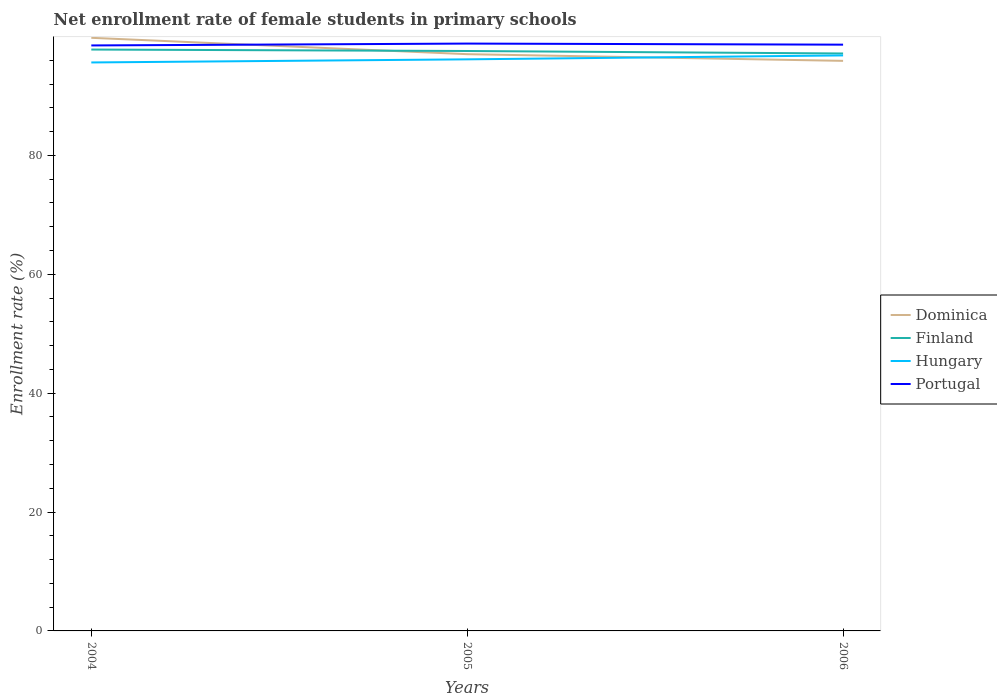Is the number of lines equal to the number of legend labels?
Offer a very short reply. Yes. Across all years, what is the maximum net enrollment rate of female students in primary schools in Finland?
Offer a terse response. 97.15. In which year was the net enrollment rate of female students in primary schools in Portugal maximum?
Your answer should be compact. 2004. What is the total net enrollment rate of female students in primary schools in Hungary in the graph?
Keep it short and to the point. -1.19. What is the difference between the highest and the second highest net enrollment rate of female students in primary schools in Portugal?
Provide a succinct answer. 0.31. Is the net enrollment rate of female students in primary schools in Hungary strictly greater than the net enrollment rate of female students in primary schools in Portugal over the years?
Ensure brevity in your answer.  Yes. What is the difference between two consecutive major ticks on the Y-axis?
Give a very brief answer. 20. Are the values on the major ticks of Y-axis written in scientific E-notation?
Offer a terse response. No. Does the graph contain grids?
Your answer should be compact. No. Where does the legend appear in the graph?
Your response must be concise. Center right. How are the legend labels stacked?
Your answer should be compact. Vertical. What is the title of the graph?
Your response must be concise. Net enrollment rate of female students in primary schools. What is the label or title of the X-axis?
Offer a terse response. Years. What is the label or title of the Y-axis?
Offer a very short reply. Enrollment rate (%). What is the Enrollment rate (%) of Dominica in 2004?
Provide a short and direct response. 99.79. What is the Enrollment rate (%) of Finland in 2004?
Your answer should be very brief. 97.82. What is the Enrollment rate (%) in Hungary in 2004?
Provide a succinct answer. 95.64. What is the Enrollment rate (%) of Portugal in 2004?
Make the answer very short. 98.51. What is the Enrollment rate (%) in Dominica in 2005?
Offer a very short reply. 97.04. What is the Enrollment rate (%) of Finland in 2005?
Your answer should be compact. 97.57. What is the Enrollment rate (%) of Hungary in 2005?
Make the answer very short. 96.17. What is the Enrollment rate (%) of Portugal in 2005?
Provide a succinct answer. 98.82. What is the Enrollment rate (%) in Dominica in 2006?
Make the answer very short. 95.91. What is the Enrollment rate (%) in Finland in 2006?
Keep it short and to the point. 97.15. What is the Enrollment rate (%) in Hungary in 2006?
Provide a short and direct response. 96.83. What is the Enrollment rate (%) of Portugal in 2006?
Ensure brevity in your answer.  98.64. Across all years, what is the maximum Enrollment rate (%) of Dominica?
Make the answer very short. 99.79. Across all years, what is the maximum Enrollment rate (%) in Finland?
Your answer should be compact. 97.82. Across all years, what is the maximum Enrollment rate (%) of Hungary?
Your response must be concise. 96.83. Across all years, what is the maximum Enrollment rate (%) of Portugal?
Provide a short and direct response. 98.82. Across all years, what is the minimum Enrollment rate (%) in Dominica?
Your answer should be very brief. 95.91. Across all years, what is the minimum Enrollment rate (%) of Finland?
Provide a succinct answer. 97.15. Across all years, what is the minimum Enrollment rate (%) in Hungary?
Your response must be concise. 95.64. Across all years, what is the minimum Enrollment rate (%) of Portugal?
Give a very brief answer. 98.51. What is the total Enrollment rate (%) in Dominica in the graph?
Your answer should be very brief. 292.74. What is the total Enrollment rate (%) of Finland in the graph?
Offer a terse response. 292.54. What is the total Enrollment rate (%) in Hungary in the graph?
Ensure brevity in your answer.  288.64. What is the total Enrollment rate (%) of Portugal in the graph?
Your response must be concise. 295.96. What is the difference between the Enrollment rate (%) of Dominica in 2004 and that in 2005?
Offer a very short reply. 2.75. What is the difference between the Enrollment rate (%) of Finland in 2004 and that in 2005?
Make the answer very short. 0.24. What is the difference between the Enrollment rate (%) of Hungary in 2004 and that in 2005?
Offer a terse response. -0.52. What is the difference between the Enrollment rate (%) of Portugal in 2004 and that in 2005?
Provide a short and direct response. -0.31. What is the difference between the Enrollment rate (%) in Dominica in 2004 and that in 2006?
Provide a succinct answer. 3.88. What is the difference between the Enrollment rate (%) of Finland in 2004 and that in 2006?
Ensure brevity in your answer.  0.66. What is the difference between the Enrollment rate (%) in Hungary in 2004 and that in 2006?
Ensure brevity in your answer.  -1.19. What is the difference between the Enrollment rate (%) in Portugal in 2004 and that in 2006?
Provide a short and direct response. -0.13. What is the difference between the Enrollment rate (%) in Dominica in 2005 and that in 2006?
Offer a very short reply. 1.12. What is the difference between the Enrollment rate (%) in Finland in 2005 and that in 2006?
Make the answer very short. 0.42. What is the difference between the Enrollment rate (%) in Hungary in 2005 and that in 2006?
Your answer should be compact. -0.66. What is the difference between the Enrollment rate (%) in Portugal in 2005 and that in 2006?
Your answer should be very brief. 0.18. What is the difference between the Enrollment rate (%) of Dominica in 2004 and the Enrollment rate (%) of Finland in 2005?
Provide a short and direct response. 2.22. What is the difference between the Enrollment rate (%) of Dominica in 2004 and the Enrollment rate (%) of Hungary in 2005?
Give a very brief answer. 3.62. What is the difference between the Enrollment rate (%) of Dominica in 2004 and the Enrollment rate (%) of Portugal in 2005?
Your answer should be compact. 0.97. What is the difference between the Enrollment rate (%) of Finland in 2004 and the Enrollment rate (%) of Hungary in 2005?
Ensure brevity in your answer.  1.65. What is the difference between the Enrollment rate (%) in Finland in 2004 and the Enrollment rate (%) in Portugal in 2005?
Give a very brief answer. -1. What is the difference between the Enrollment rate (%) of Hungary in 2004 and the Enrollment rate (%) of Portugal in 2005?
Offer a terse response. -3.18. What is the difference between the Enrollment rate (%) in Dominica in 2004 and the Enrollment rate (%) in Finland in 2006?
Keep it short and to the point. 2.64. What is the difference between the Enrollment rate (%) of Dominica in 2004 and the Enrollment rate (%) of Hungary in 2006?
Keep it short and to the point. 2.96. What is the difference between the Enrollment rate (%) in Dominica in 2004 and the Enrollment rate (%) in Portugal in 2006?
Offer a very short reply. 1.15. What is the difference between the Enrollment rate (%) of Finland in 2004 and the Enrollment rate (%) of Hungary in 2006?
Provide a succinct answer. 0.99. What is the difference between the Enrollment rate (%) in Finland in 2004 and the Enrollment rate (%) in Portugal in 2006?
Provide a short and direct response. -0.82. What is the difference between the Enrollment rate (%) of Hungary in 2004 and the Enrollment rate (%) of Portugal in 2006?
Give a very brief answer. -2.99. What is the difference between the Enrollment rate (%) of Dominica in 2005 and the Enrollment rate (%) of Finland in 2006?
Offer a very short reply. -0.12. What is the difference between the Enrollment rate (%) of Dominica in 2005 and the Enrollment rate (%) of Hungary in 2006?
Your answer should be compact. 0.21. What is the difference between the Enrollment rate (%) in Dominica in 2005 and the Enrollment rate (%) in Portugal in 2006?
Your response must be concise. -1.6. What is the difference between the Enrollment rate (%) of Finland in 2005 and the Enrollment rate (%) of Hungary in 2006?
Ensure brevity in your answer.  0.74. What is the difference between the Enrollment rate (%) in Finland in 2005 and the Enrollment rate (%) in Portugal in 2006?
Offer a terse response. -1.07. What is the difference between the Enrollment rate (%) of Hungary in 2005 and the Enrollment rate (%) of Portugal in 2006?
Your response must be concise. -2.47. What is the average Enrollment rate (%) in Dominica per year?
Ensure brevity in your answer.  97.58. What is the average Enrollment rate (%) in Finland per year?
Provide a short and direct response. 97.51. What is the average Enrollment rate (%) of Hungary per year?
Provide a succinct answer. 96.21. What is the average Enrollment rate (%) in Portugal per year?
Offer a terse response. 98.65. In the year 2004, what is the difference between the Enrollment rate (%) in Dominica and Enrollment rate (%) in Finland?
Offer a terse response. 1.97. In the year 2004, what is the difference between the Enrollment rate (%) in Dominica and Enrollment rate (%) in Hungary?
Your answer should be compact. 4.15. In the year 2004, what is the difference between the Enrollment rate (%) in Dominica and Enrollment rate (%) in Portugal?
Ensure brevity in your answer.  1.28. In the year 2004, what is the difference between the Enrollment rate (%) in Finland and Enrollment rate (%) in Hungary?
Provide a short and direct response. 2.17. In the year 2004, what is the difference between the Enrollment rate (%) in Finland and Enrollment rate (%) in Portugal?
Provide a short and direct response. -0.69. In the year 2004, what is the difference between the Enrollment rate (%) in Hungary and Enrollment rate (%) in Portugal?
Your answer should be compact. -2.87. In the year 2005, what is the difference between the Enrollment rate (%) in Dominica and Enrollment rate (%) in Finland?
Provide a succinct answer. -0.53. In the year 2005, what is the difference between the Enrollment rate (%) in Dominica and Enrollment rate (%) in Hungary?
Give a very brief answer. 0.87. In the year 2005, what is the difference between the Enrollment rate (%) of Dominica and Enrollment rate (%) of Portugal?
Your answer should be very brief. -1.78. In the year 2005, what is the difference between the Enrollment rate (%) of Finland and Enrollment rate (%) of Hungary?
Provide a short and direct response. 1.41. In the year 2005, what is the difference between the Enrollment rate (%) of Finland and Enrollment rate (%) of Portugal?
Your response must be concise. -1.25. In the year 2005, what is the difference between the Enrollment rate (%) in Hungary and Enrollment rate (%) in Portugal?
Your answer should be compact. -2.65. In the year 2006, what is the difference between the Enrollment rate (%) of Dominica and Enrollment rate (%) of Finland?
Make the answer very short. -1.24. In the year 2006, what is the difference between the Enrollment rate (%) of Dominica and Enrollment rate (%) of Hungary?
Provide a short and direct response. -0.92. In the year 2006, what is the difference between the Enrollment rate (%) in Dominica and Enrollment rate (%) in Portugal?
Your answer should be compact. -2.72. In the year 2006, what is the difference between the Enrollment rate (%) in Finland and Enrollment rate (%) in Hungary?
Ensure brevity in your answer.  0.33. In the year 2006, what is the difference between the Enrollment rate (%) in Finland and Enrollment rate (%) in Portugal?
Provide a short and direct response. -1.48. In the year 2006, what is the difference between the Enrollment rate (%) in Hungary and Enrollment rate (%) in Portugal?
Your response must be concise. -1.81. What is the ratio of the Enrollment rate (%) in Dominica in 2004 to that in 2005?
Provide a short and direct response. 1.03. What is the ratio of the Enrollment rate (%) of Portugal in 2004 to that in 2005?
Keep it short and to the point. 1. What is the ratio of the Enrollment rate (%) in Dominica in 2004 to that in 2006?
Keep it short and to the point. 1.04. What is the ratio of the Enrollment rate (%) in Finland in 2004 to that in 2006?
Keep it short and to the point. 1.01. What is the ratio of the Enrollment rate (%) of Hungary in 2004 to that in 2006?
Give a very brief answer. 0.99. What is the ratio of the Enrollment rate (%) in Portugal in 2004 to that in 2006?
Provide a short and direct response. 1. What is the ratio of the Enrollment rate (%) in Dominica in 2005 to that in 2006?
Provide a succinct answer. 1.01. What is the ratio of the Enrollment rate (%) in Hungary in 2005 to that in 2006?
Offer a terse response. 0.99. What is the difference between the highest and the second highest Enrollment rate (%) of Dominica?
Give a very brief answer. 2.75. What is the difference between the highest and the second highest Enrollment rate (%) in Finland?
Keep it short and to the point. 0.24. What is the difference between the highest and the second highest Enrollment rate (%) of Hungary?
Your answer should be very brief. 0.66. What is the difference between the highest and the second highest Enrollment rate (%) of Portugal?
Give a very brief answer. 0.18. What is the difference between the highest and the lowest Enrollment rate (%) in Dominica?
Keep it short and to the point. 3.88. What is the difference between the highest and the lowest Enrollment rate (%) in Finland?
Offer a terse response. 0.66. What is the difference between the highest and the lowest Enrollment rate (%) of Hungary?
Offer a terse response. 1.19. What is the difference between the highest and the lowest Enrollment rate (%) in Portugal?
Ensure brevity in your answer.  0.31. 